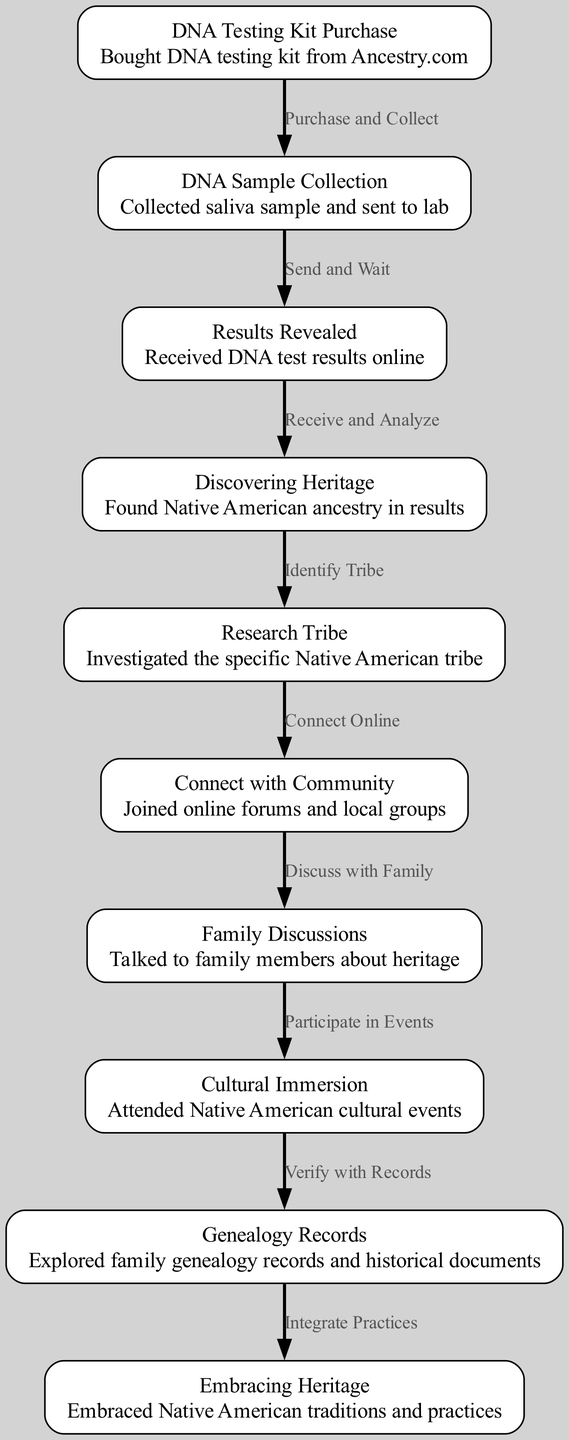What is the first step in the journey? The first step is labeled "DNA Testing Kit Purchase," which indicates that the individual bought a DNA testing kit from Ancestry.com.
Answer: DNA Testing Kit Purchase How many nodes are in the diagram? By counting each unique step in the journey represented by the nodes, there are a total of ten nodes listed in the diagram.
Answer: 10 What does the edge from "Results Revealed" to "Discovering Heritage" signify? This edge is labeled "Receive and Analyze," indicating the process of analyzing the DNA test results leads to discovering Native American ancestry.
Answer: Receive and Analyze Which step comes after "Family Discussions"? The diagram shows that after "Family Discussions," the next step is "Cultural Immersion."
Answer: Cultural Immersion What is the final step of the journey? The last step in the journey is labeled "Embracing Heritage," which signifies the individual embracing Native American traditions and practices.
Answer: Embracing Heritage Identify the relationship between "Connect with Community" and "Family Discussions." The edge between "Connect with Community" and "Family Discussions" is labeled "Discuss with Family," indicating discussions about heritage take place after connecting with the community.
Answer: Discuss with Family How many edges are there connecting the nodes? By examining the connections between the various steps, there are a total of nine edges illustrated in the diagram.
Answer: 9 What specific action is taken after discovering heritage? After discovering heritage, the action taken is to "Research Tribe," where the individual investigates the specific Native American tribe they have ancestry from.
Answer: Research Tribe What step involves verification with genealogy records? The step that involves verification with genealogy records is "Verify with Records," which connects "Cultural Immersion" and "Embracing Heritage."
Answer: Verify with Records 